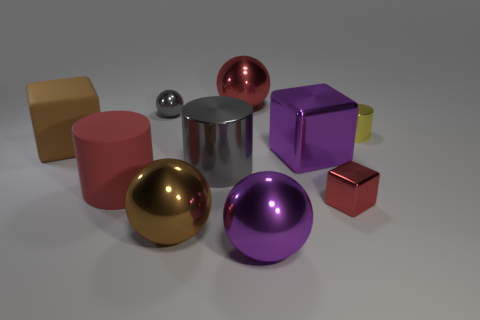What is the color of the big cylinder that is made of the same material as the small cylinder?
Provide a succinct answer. Gray. Is the number of red cylinders that are to the right of the yellow object less than the number of large gray rubber cylinders?
Offer a terse response. No. There is another gray object that is the same material as the small gray object; what shape is it?
Ensure brevity in your answer.  Cylinder. What number of rubber things are either tiny red cubes or small gray blocks?
Keep it short and to the point. 0. Are there the same number of tiny metallic balls on the right side of the gray ball and cylinders?
Give a very brief answer. No. There is a large block right of the big red rubber cylinder; is its color the same as the small ball?
Your answer should be compact. No. What is the material of the cylinder that is to the right of the red rubber object and in front of the brown rubber cube?
Your answer should be very brief. Metal. Is there a cube that is to the right of the gray thing behind the large gray thing?
Give a very brief answer. Yes. Do the tiny sphere and the tiny red object have the same material?
Your answer should be compact. Yes. There is a object that is both to the left of the small gray thing and right of the large brown block; what shape is it?
Make the answer very short. Cylinder. 